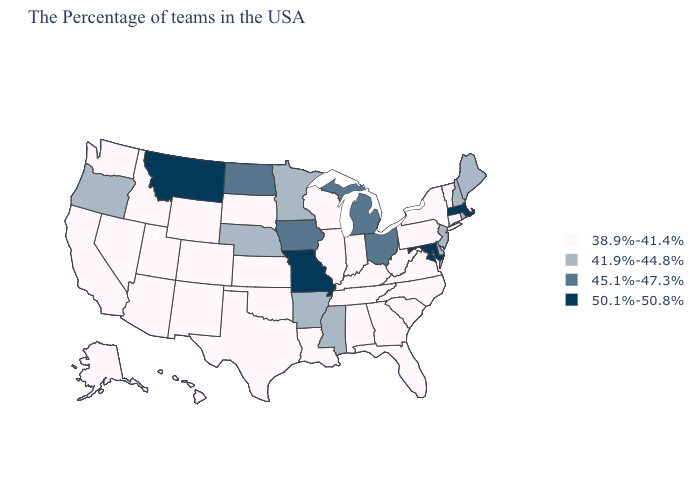What is the lowest value in the Northeast?
Concise answer only. 38.9%-41.4%. What is the value of Utah?
Keep it brief. 38.9%-41.4%. Among the states that border Delaware , which have the lowest value?
Give a very brief answer. Pennsylvania. Does South Carolina have the highest value in the USA?
Write a very short answer. No. Name the states that have a value in the range 45.1%-47.3%?
Concise answer only. Ohio, Michigan, Iowa, North Dakota. What is the lowest value in the USA?
Quick response, please. 38.9%-41.4%. What is the value of Louisiana?
Quick response, please. 38.9%-41.4%. What is the value of Virginia?
Be succinct. 38.9%-41.4%. What is the highest value in the USA?
Write a very short answer. 50.1%-50.8%. What is the highest value in the USA?
Write a very short answer. 50.1%-50.8%. Does the map have missing data?
Write a very short answer. No. What is the highest value in the USA?
Write a very short answer. 50.1%-50.8%. What is the value of Vermont?
Keep it brief. 38.9%-41.4%. Among the states that border California , does Oregon have the lowest value?
Quick response, please. No. How many symbols are there in the legend?
Keep it brief. 4. 